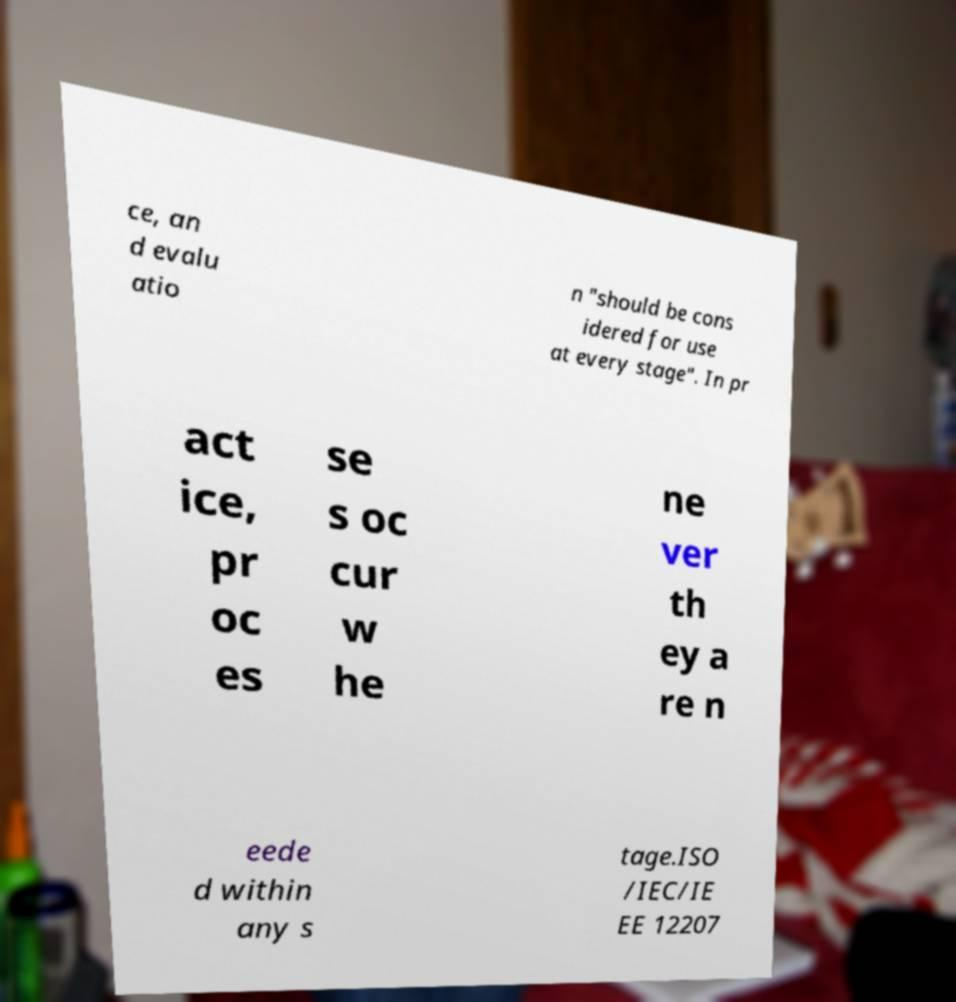What messages or text are displayed in this image? I need them in a readable, typed format. ce, an d evalu atio n "should be cons idered for use at every stage". In pr act ice, pr oc es se s oc cur w he ne ver th ey a re n eede d within any s tage.ISO /IEC/IE EE 12207 